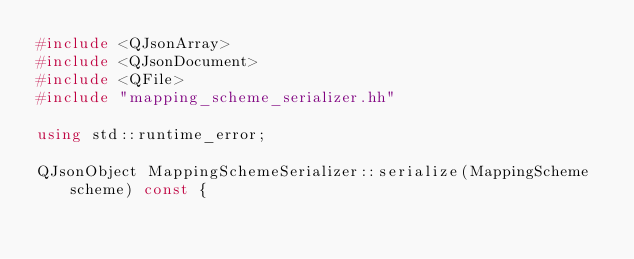Convert code to text. <code><loc_0><loc_0><loc_500><loc_500><_C++_>#include <QJsonArray>
#include <QJsonDocument>
#include <QFile>
#include "mapping_scheme_serializer.hh"

using std::runtime_error;

QJsonObject MappingSchemeSerializer::serialize(MappingScheme scheme) const {</code> 